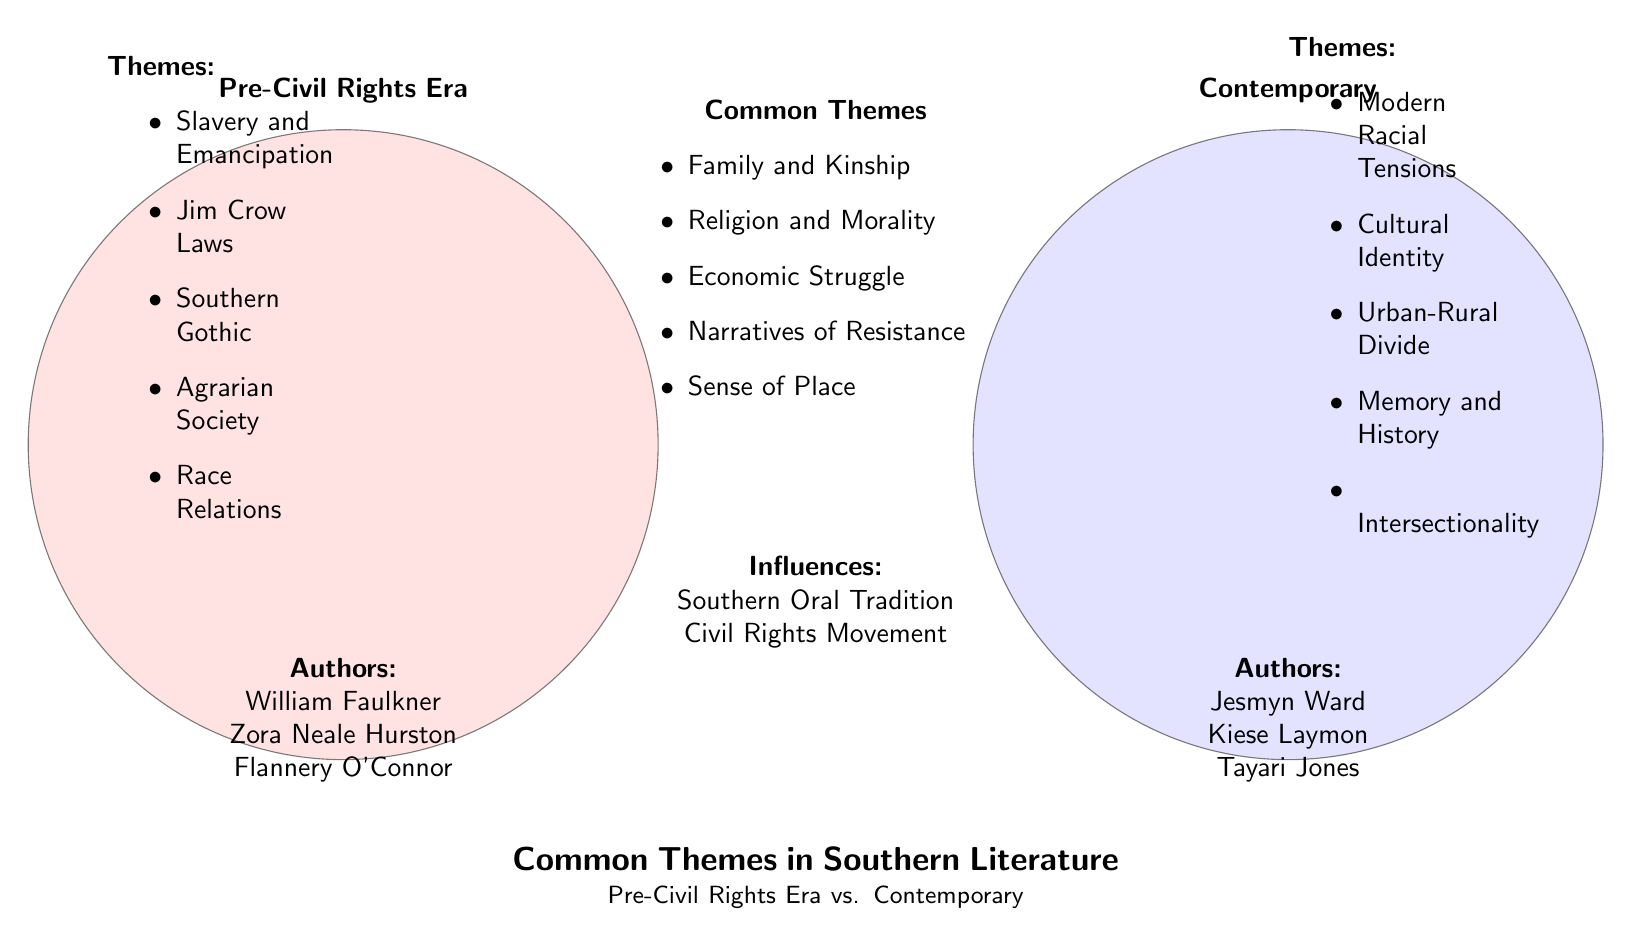What themes are listed under Pre-Civil Rights Era? The diagram lists five themes under Pre-Civil Rights Era. They include Slavery and Emancipation, Jim Crow Laws, Southern Gothic, Agrarian Society, and Race Relations. These themes are clearly outlined in the left circle of the Venn diagram.
Answer: Slavery and Emancipation, Jim Crow Laws, Southern Gothic, Agrarian Society, Race Relations Who are the authors associated with Contemporary Southern novels? In the right circle of the diagram, three authors are mentioned as associated with Contemporary Southern novels: Jesmyn Ward, Kiese Laymon, and Tayari Jones. This information is explicitly stated under the Contemporary section.
Answer: Jesmyn Ward, Kiese Laymon, Tayari Jones What do the common themes focus on? The common themes outlined in the overlapping area of the diagram include Family and Kinship, Religion and Morality, Economic Struggle, Narratives of Resistance, and Sense of Place. These themes highlight the shared experiences and cultural narratives present in both eras.
Answer: Family and Kinship, Religion and Morality, Economic Struggle, Narratives of Resistance, Sense of Place How many themes are uniquely associated with the Pre-Civil Rights Era? The diagram shows five themes specifically listed under Pre-Civil Rights Era. This count can be reached by directly enumerating the bullet points in that section of the diagram.
Answer: 5 What influences are noted as common to both eras in the diagram? The diagram notes two influences that are common to both Pre-Civil Rights Era and Contemporary Southern literature: the Southern Oral Tradition and the Civil Rights Movement. These influences reflect the broader social and cultural contexts shaping Southern literature.
Answer: Southern Oral Tradition, Civil Rights Movement Which thematic element is related to the intersection of race in contemporary literature? The diagram mentions "Modern Racial Tensions" as a theme under Contemporary Southern novels, indicating a focus on how race continues to evolve and affect identity in modern narratives.
Answer: Modern Racial Tensions What is the main purpose of the diagram? The primary purpose of this Venn diagram is to illustrate the common themes and distinct differences between Southern literature from the Pre-Civil Rights Era and contemporary works, emphasizing both continuity and change in the themes presented.
Answer: Compare themes in Southern literature What is one common theme regarding the socio-economic condition in both eras? One common theme concerning socio-economic conditions in both Pre-Civil Rights and Contemporary Southern literature is "Economic Struggle," highlighting the persistent challenges faced by individuals in the South related to economic disparities.
Answer: Economic Struggle 